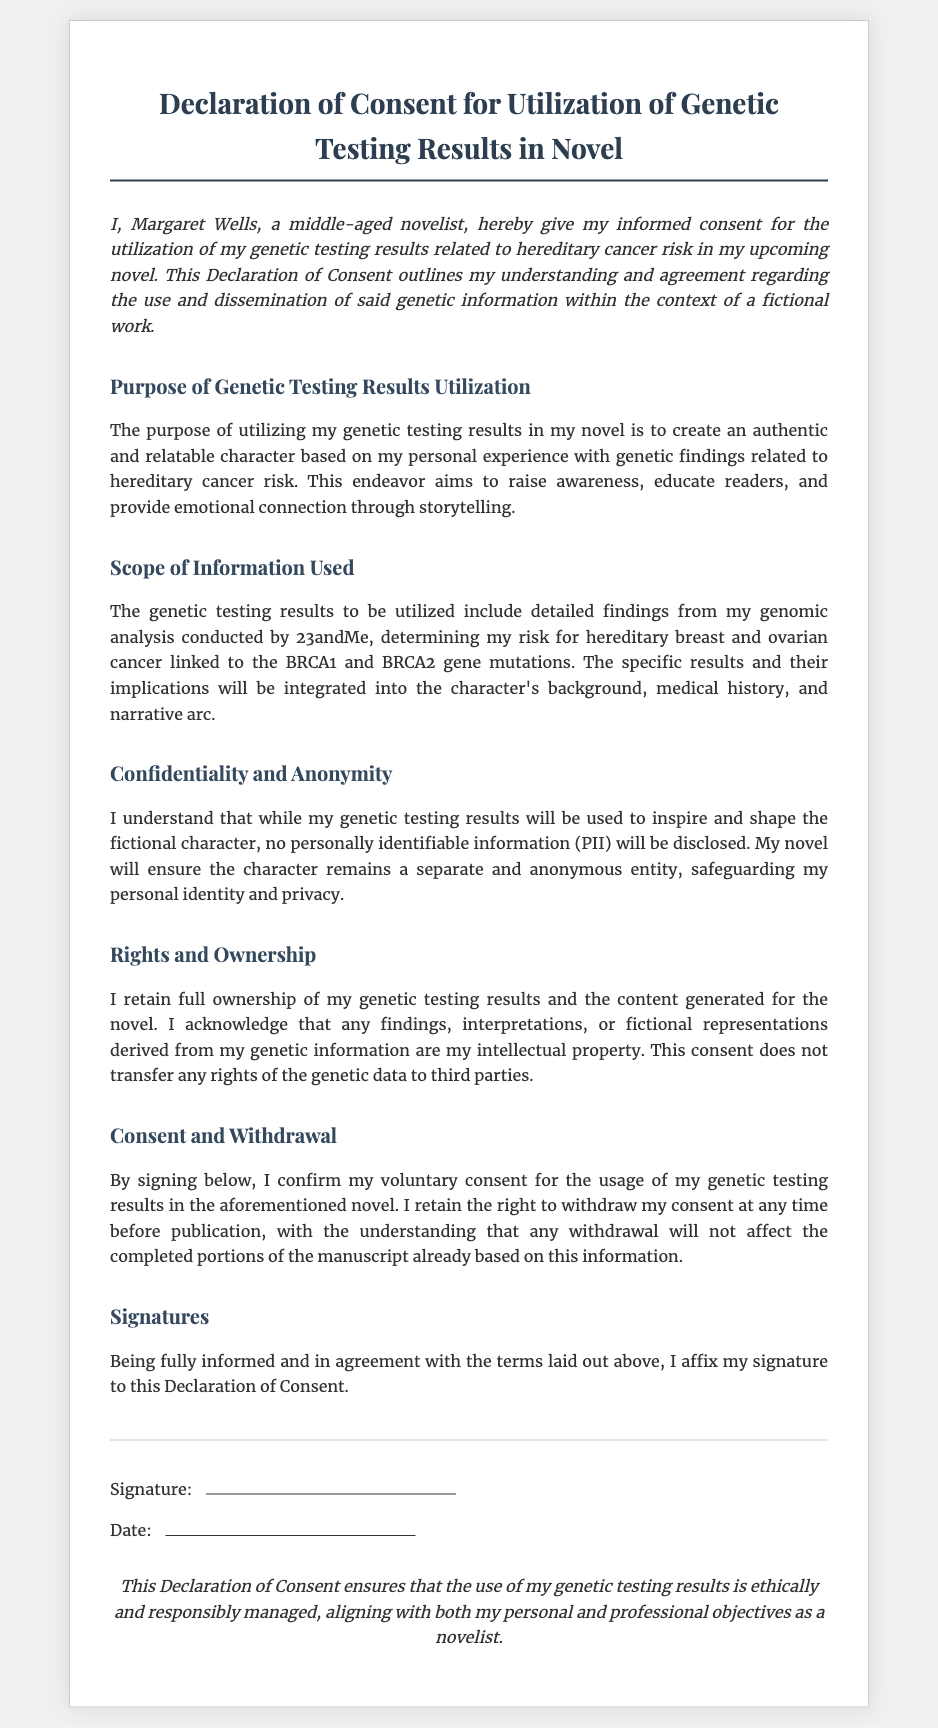What is the title of the document? The title is clearly stated at the top of the document.
Answer: Declaration of Consent for Utilization of Genetic Testing Results in Novel Who is the declarant of this consent? The document contains the name of the individual providing consent.
Answer: Margaret Wells What is the genetic testing company mentioned? The document specifies which company conducted the genomic analysis.
Answer: 23andMe What specific cancer risks are referenced in the document? The document outlines the hereditary cancer risks related to specific gene mutations.
Answer: hereditary breast and ovarian cancer What rights does the declarant retain over their genetic testing results? The document states the rights related to ownership and intellectual property concerning the genetic data.
Answer: full ownership What can the declarant do regarding their consent before publication? The document mentions the action the declarant can take concerning their consent.
Answer: withdraw What type of information will not be disclosed in the novel? The document ensures protection of certain sensitive information.
Answer: personally identifiable information How is the document signed? The document includes a section related to the signature format.
Answer: Signature and Date 